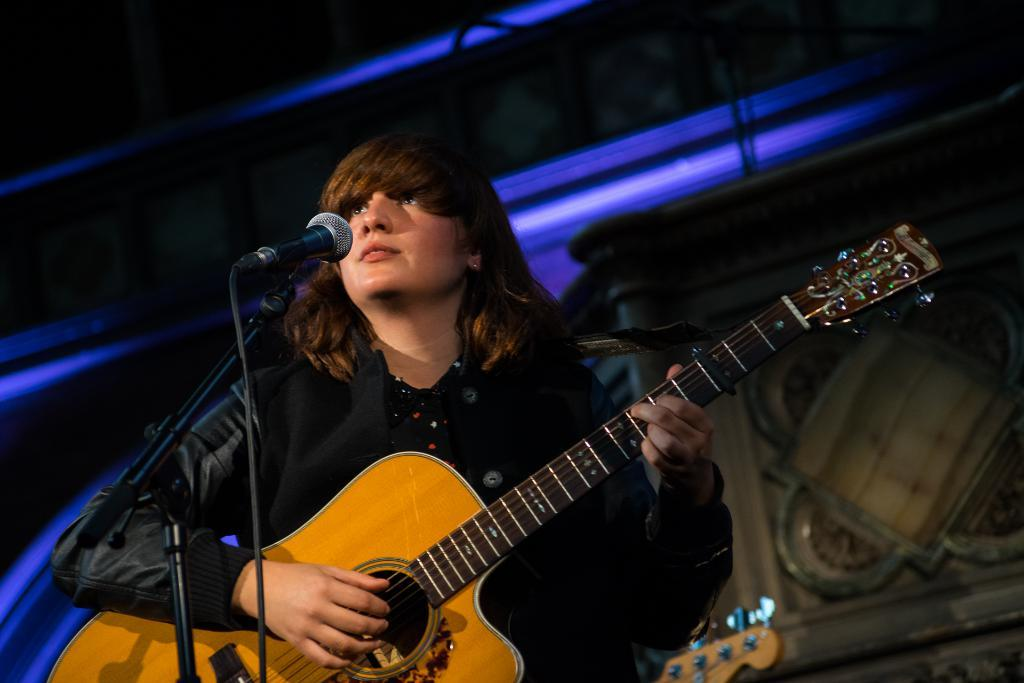Who is the main subject in the image? There is a woman in the image. What is the woman holding in the image? The woman is holding a guitar. What is the woman doing with the guitar? The woman is playing the guitar. What is the woman doing while playing the guitar? The woman is singing on a microphone. What can be seen in the background of the image? There is light and a wall in the background of the image. How would you describe the overall lighting in the image? The image appears to be dark. Reasoning: Let' Let's think step by step in order to produce the conversation. We start by identifying the main subject in the image, which is the woman. Then, we describe what the woman is doing and holding, which are playing the guitar and holding a microphone. We also mention the background elements, such as the light and wall. Finally, we describe the overall lighting in the image as dark. Absurd Question/Answer: What type of sand can be seen in the image? There is no sand present in the image. What time of day is it in the image, considering the afternoon? The time of day is not mentioned or indicated in the image, so it cannot be determined based on the provided facts. 